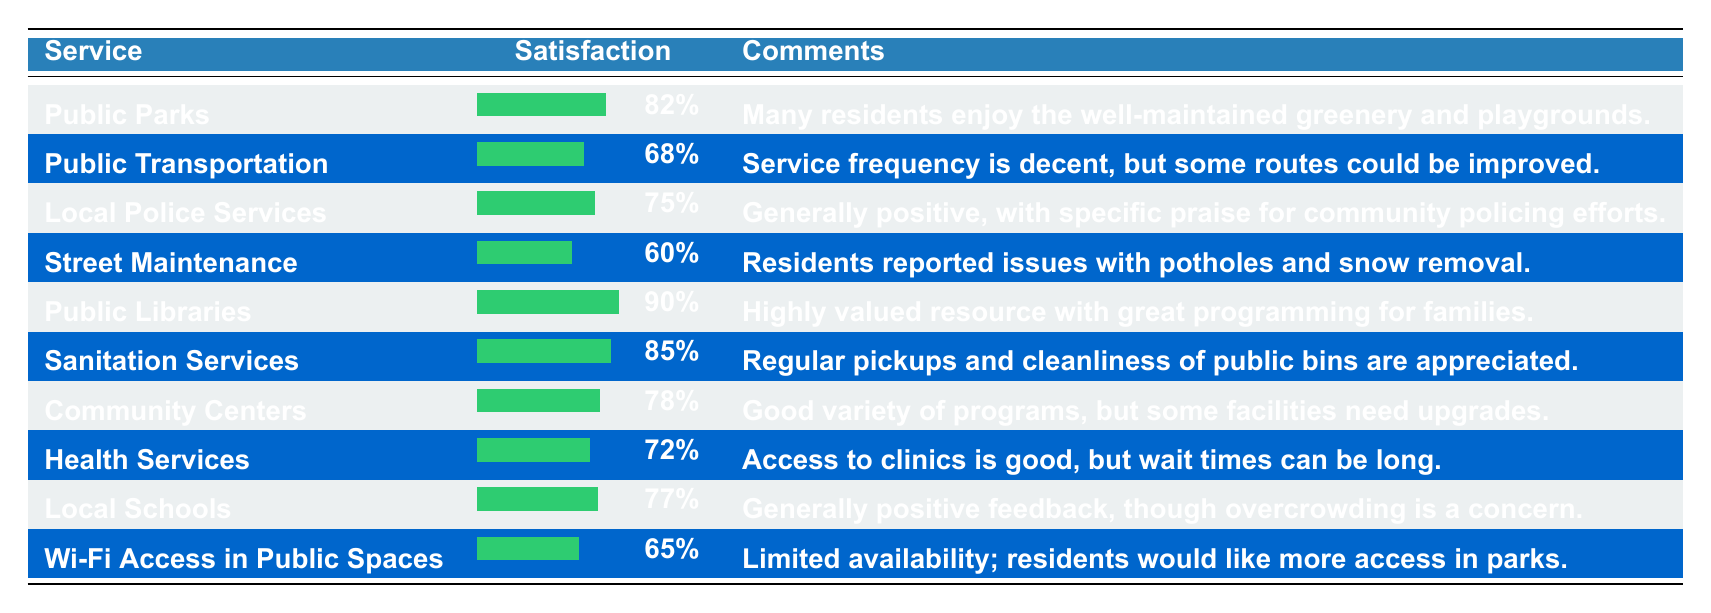What is the satisfaction rate for Public Parks? The table shows the satisfaction rate for Public Parks as 82%.
Answer: 82% What are the comments about Public Libraries? According to the table, residents view Public Libraries as a highly valued resource with great programming for families.
Answer: Highly valued resource with great programming for families Which service has the highest satisfaction rate? The service with the highest satisfaction rate is Public Libraries at 90%.
Answer: Public Libraries What is the average satisfaction rate for the services listed? To calculate the average satisfaction rate, sum the satisfaction rates (82 + 68 + 75 + 60 + 90 + 85 + 78 + 72 + 77 + 65 =  81.7), then divide by the number of services (10). The average is 81.7%.
Answer: 81.7% Is the satisfaction rate for Street Maintenance above 70%? The satisfaction rate for Street Maintenance is 60%, which is below 70%.
Answer: No What is the difference in satisfaction rates between Public Parks and Wi-Fi Access in Public Spaces? Public Parks has a satisfaction rate of 82% while Wi-Fi Access has 65%. The difference is 82 - 65 = 17%.
Answer: 17% How many services have a satisfaction rate above 75%? The services with a satisfaction rate above 75% are Public Parks, Local Police Services, Public Libraries, and Sanitation Services, totaling 4 services.
Answer: 4 Do residents feel positively about Street Maintenance based on satisfaction? Yes, the comments indicate issues with potholes and snow removal, which reflects a negative perception, aligning with the low satisfaction rate of 60%.
Answer: No What is the satisfaction rate for Health Services and how does it compare to Local Schools? Health Services has a satisfaction rate of 72% which is lower than Local Schools at 77%; thus, Health Services is less appreciated in satisfaction.
Answer: Lower than Local Schools What percentage of residents are satisfied with Sanitation Services compared to Public Transportation? Sanitation Services has a satisfaction rate of 85%, while Public Transportation has 68%. The difference indicates Sanitation Services is rated 17% higher.
Answer: 17% higher 